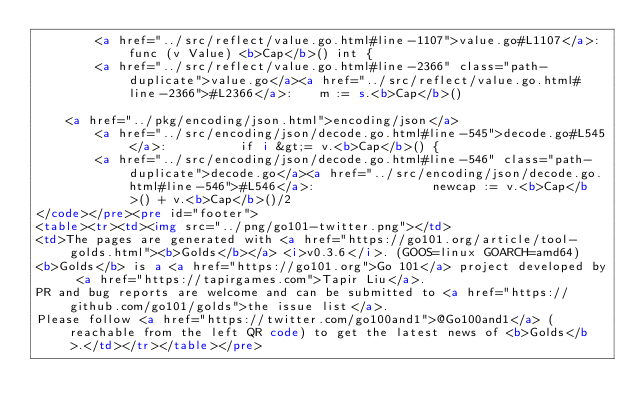<code> <loc_0><loc_0><loc_500><loc_500><_HTML_>		<a href="../src/reflect/value.go.html#line-1107">value.go#L1107</a>: func (v Value) <b>Cap</b>() int {
		<a href="../src/reflect/value.go.html#line-2366" class="path-duplicate">value.go</a><a href="../src/reflect/value.go.html#line-2366">#L2366</a>: 	m := s.<b>Cap</b>()

	<a href="../pkg/encoding/json.html">encoding/json</a>
		<a href="../src/encoding/json/decode.go.html#line-545">decode.go#L545</a>: 			if i &gt;= v.<b>Cap</b>() {
		<a href="../src/encoding/json/decode.go.html#line-546" class="path-duplicate">decode.go</a><a href="../src/encoding/json/decode.go.html#line-546">#L546</a>: 				newcap := v.<b>Cap</b>() + v.<b>Cap</b>()/2
</code></pre><pre id="footer">
<table><tr><td><img src="../png/go101-twitter.png"></td>
<td>The pages are generated with <a href="https://go101.org/article/tool-golds.html"><b>Golds</b></a> <i>v0.3.6</i>. (GOOS=linux GOARCH=amd64)
<b>Golds</b> is a <a href="https://go101.org">Go 101</a> project developed by <a href="https://tapirgames.com">Tapir Liu</a>.
PR and bug reports are welcome and can be submitted to <a href="https://github.com/go101/golds">the issue list</a>.
Please follow <a href="https://twitter.com/go100and1">@Go100and1</a> (reachable from the left QR code) to get the latest news of <b>Golds</b>.</td></tr></table></pre></code> 